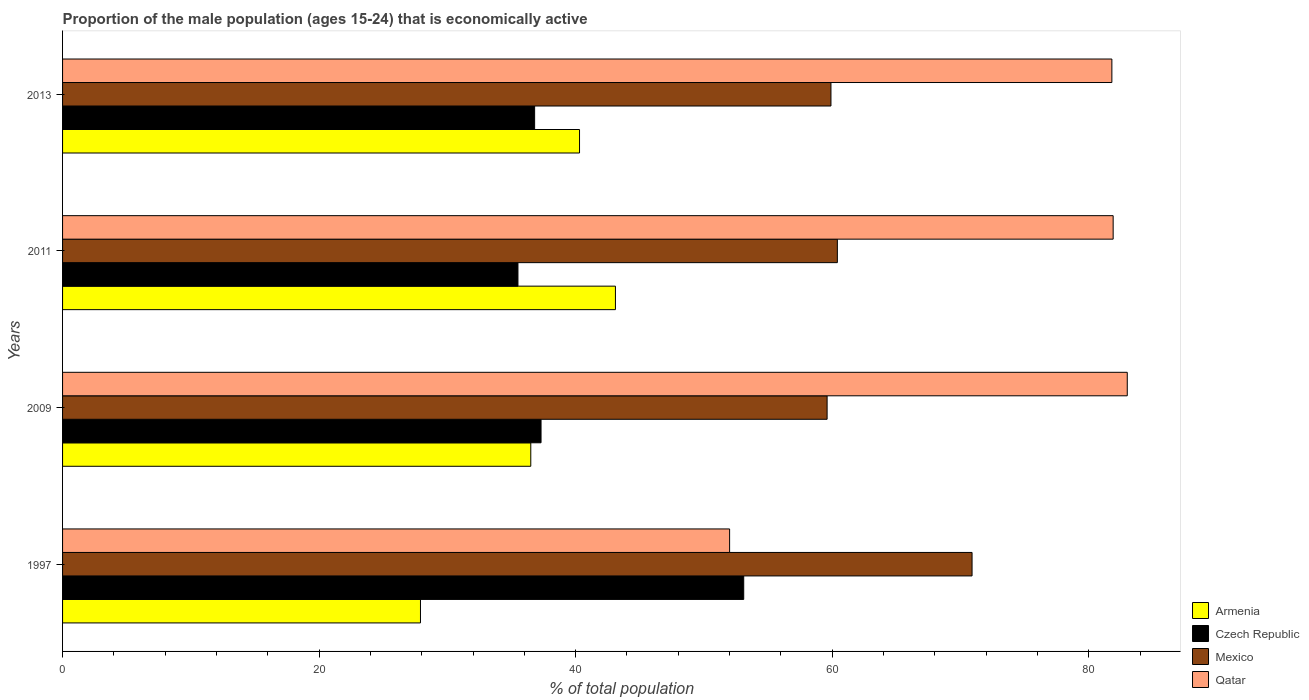How many different coloured bars are there?
Provide a short and direct response. 4. How many groups of bars are there?
Provide a succinct answer. 4. Are the number of bars on each tick of the Y-axis equal?
Offer a very short reply. Yes. What is the proportion of the male population that is economically active in Mexico in 1997?
Your response must be concise. 70.9. Across all years, what is the minimum proportion of the male population that is economically active in Mexico?
Your response must be concise. 59.6. In which year was the proportion of the male population that is economically active in Armenia maximum?
Provide a short and direct response. 2011. What is the total proportion of the male population that is economically active in Czech Republic in the graph?
Your answer should be very brief. 162.7. What is the difference between the proportion of the male population that is economically active in Qatar in 1997 and that in 2011?
Make the answer very short. -29.9. What is the difference between the proportion of the male population that is economically active in Mexico in 2011 and the proportion of the male population that is economically active in Czech Republic in 2013?
Provide a short and direct response. 23.6. What is the average proportion of the male population that is economically active in Czech Republic per year?
Make the answer very short. 40.67. In the year 2011, what is the difference between the proportion of the male population that is economically active in Mexico and proportion of the male population that is economically active in Czech Republic?
Offer a very short reply. 24.9. In how many years, is the proportion of the male population that is economically active in Qatar greater than 56 %?
Your response must be concise. 3. What is the ratio of the proportion of the male population that is economically active in Armenia in 2009 to that in 2011?
Your answer should be very brief. 0.85. Is the proportion of the male population that is economically active in Armenia in 1997 less than that in 2009?
Your answer should be very brief. Yes. What is the difference between the highest and the second highest proportion of the male population that is economically active in Mexico?
Your response must be concise. 10.5. Is the sum of the proportion of the male population that is economically active in Qatar in 2009 and 2013 greater than the maximum proportion of the male population that is economically active in Armenia across all years?
Your response must be concise. Yes. Is it the case that in every year, the sum of the proportion of the male population that is economically active in Czech Republic and proportion of the male population that is economically active in Qatar is greater than the sum of proportion of the male population that is economically active in Mexico and proportion of the male population that is economically active in Armenia?
Your answer should be compact. Yes. What does the 4th bar from the top in 1997 represents?
Offer a very short reply. Armenia. What does the 2nd bar from the bottom in 1997 represents?
Offer a terse response. Czech Republic. How many bars are there?
Offer a terse response. 16. Are all the bars in the graph horizontal?
Ensure brevity in your answer.  Yes. How many years are there in the graph?
Give a very brief answer. 4. What is the difference between two consecutive major ticks on the X-axis?
Keep it short and to the point. 20. Are the values on the major ticks of X-axis written in scientific E-notation?
Your answer should be very brief. No. Does the graph contain any zero values?
Offer a terse response. No. Does the graph contain grids?
Provide a short and direct response. No. Where does the legend appear in the graph?
Your response must be concise. Bottom right. How many legend labels are there?
Provide a succinct answer. 4. How are the legend labels stacked?
Ensure brevity in your answer.  Vertical. What is the title of the graph?
Make the answer very short. Proportion of the male population (ages 15-24) that is economically active. Does "New Zealand" appear as one of the legend labels in the graph?
Your answer should be compact. No. What is the label or title of the X-axis?
Provide a short and direct response. % of total population. What is the % of total population in Armenia in 1997?
Provide a succinct answer. 27.9. What is the % of total population of Czech Republic in 1997?
Give a very brief answer. 53.1. What is the % of total population of Mexico in 1997?
Provide a short and direct response. 70.9. What is the % of total population of Armenia in 2009?
Your answer should be compact. 36.5. What is the % of total population in Czech Republic in 2009?
Your answer should be compact. 37.3. What is the % of total population of Mexico in 2009?
Provide a short and direct response. 59.6. What is the % of total population in Armenia in 2011?
Make the answer very short. 43.1. What is the % of total population of Czech Republic in 2011?
Your answer should be compact. 35.5. What is the % of total population of Mexico in 2011?
Make the answer very short. 60.4. What is the % of total population in Qatar in 2011?
Give a very brief answer. 81.9. What is the % of total population of Armenia in 2013?
Offer a very short reply. 40.3. What is the % of total population in Czech Republic in 2013?
Your answer should be very brief. 36.8. What is the % of total population of Mexico in 2013?
Ensure brevity in your answer.  59.9. What is the % of total population in Qatar in 2013?
Your response must be concise. 81.8. Across all years, what is the maximum % of total population of Armenia?
Keep it short and to the point. 43.1. Across all years, what is the maximum % of total population in Czech Republic?
Your answer should be compact. 53.1. Across all years, what is the maximum % of total population in Mexico?
Provide a short and direct response. 70.9. Across all years, what is the maximum % of total population of Qatar?
Give a very brief answer. 83. Across all years, what is the minimum % of total population of Armenia?
Provide a succinct answer. 27.9. Across all years, what is the minimum % of total population in Czech Republic?
Provide a short and direct response. 35.5. Across all years, what is the minimum % of total population in Mexico?
Give a very brief answer. 59.6. What is the total % of total population in Armenia in the graph?
Make the answer very short. 147.8. What is the total % of total population of Czech Republic in the graph?
Give a very brief answer. 162.7. What is the total % of total population in Mexico in the graph?
Offer a very short reply. 250.8. What is the total % of total population in Qatar in the graph?
Give a very brief answer. 298.7. What is the difference between the % of total population of Czech Republic in 1997 and that in 2009?
Your answer should be very brief. 15.8. What is the difference between the % of total population of Qatar in 1997 and that in 2009?
Make the answer very short. -31. What is the difference between the % of total population in Armenia in 1997 and that in 2011?
Offer a terse response. -15.2. What is the difference between the % of total population in Qatar in 1997 and that in 2011?
Your answer should be very brief. -29.9. What is the difference between the % of total population of Armenia in 1997 and that in 2013?
Ensure brevity in your answer.  -12.4. What is the difference between the % of total population of Czech Republic in 1997 and that in 2013?
Provide a short and direct response. 16.3. What is the difference between the % of total population of Qatar in 1997 and that in 2013?
Your response must be concise. -29.8. What is the difference between the % of total population in Czech Republic in 2009 and that in 2011?
Make the answer very short. 1.8. What is the difference between the % of total population in Qatar in 2009 and that in 2011?
Give a very brief answer. 1.1. What is the difference between the % of total population of Czech Republic in 2009 and that in 2013?
Your response must be concise. 0.5. What is the difference between the % of total population of Mexico in 2009 and that in 2013?
Provide a succinct answer. -0.3. What is the difference between the % of total population of Armenia in 1997 and the % of total population of Mexico in 2009?
Ensure brevity in your answer.  -31.7. What is the difference between the % of total population in Armenia in 1997 and the % of total population in Qatar in 2009?
Keep it short and to the point. -55.1. What is the difference between the % of total population of Czech Republic in 1997 and the % of total population of Mexico in 2009?
Keep it short and to the point. -6.5. What is the difference between the % of total population of Czech Republic in 1997 and the % of total population of Qatar in 2009?
Your answer should be very brief. -29.9. What is the difference between the % of total population of Armenia in 1997 and the % of total population of Mexico in 2011?
Your answer should be compact. -32.5. What is the difference between the % of total population in Armenia in 1997 and the % of total population in Qatar in 2011?
Your response must be concise. -54. What is the difference between the % of total population of Czech Republic in 1997 and the % of total population of Mexico in 2011?
Your answer should be compact. -7.3. What is the difference between the % of total population in Czech Republic in 1997 and the % of total population in Qatar in 2011?
Make the answer very short. -28.8. What is the difference between the % of total population in Mexico in 1997 and the % of total population in Qatar in 2011?
Offer a very short reply. -11. What is the difference between the % of total population of Armenia in 1997 and the % of total population of Czech Republic in 2013?
Your answer should be very brief. -8.9. What is the difference between the % of total population in Armenia in 1997 and the % of total population in Mexico in 2013?
Offer a terse response. -32. What is the difference between the % of total population in Armenia in 1997 and the % of total population in Qatar in 2013?
Your answer should be compact. -53.9. What is the difference between the % of total population of Czech Republic in 1997 and the % of total population of Qatar in 2013?
Your answer should be compact. -28.7. What is the difference between the % of total population in Mexico in 1997 and the % of total population in Qatar in 2013?
Offer a terse response. -10.9. What is the difference between the % of total population in Armenia in 2009 and the % of total population in Mexico in 2011?
Your response must be concise. -23.9. What is the difference between the % of total population in Armenia in 2009 and the % of total population in Qatar in 2011?
Your response must be concise. -45.4. What is the difference between the % of total population of Czech Republic in 2009 and the % of total population of Mexico in 2011?
Give a very brief answer. -23.1. What is the difference between the % of total population of Czech Republic in 2009 and the % of total population of Qatar in 2011?
Your answer should be very brief. -44.6. What is the difference between the % of total population in Mexico in 2009 and the % of total population in Qatar in 2011?
Offer a very short reply. -22.3. What is the difference between the % of total population in Armenia in 2009 and the % of total population in Czech Republic in 2013?
Offer a terse response. -0.3. What is the difference between the % of total population of Armenia in 2009 and the % of total population of Mexico in 2013?
Provide a succinct answer. -23.4. What is the difference between the % of total population in Armenia in 2009 and the % of total population in Qatar in 2013?
Your answer should be very brief. -45.3. What is the difference between the % of total population in Czech Republic in 2009 and the % of total population in Mexico in 2013?
Make the answer very short. -22.6. What is the difference between the % of total population of Czech Republic in 2009 and the % of total population of Qatar in 2013?
Your response must be concise. -44.5. What is the difference between the % of total population in Mexico in 2009 and the % of total population in Qatar in 2013?
Make the answer very short. -22.2. What is the difference between the % of total population of Armenia in 2011 and the % of total population of Czech Republic in 2013?
Offer a very short reply. 6.3. What is the difference between the % of total population of Armenia in 2011 and the % of total population of Mexico in 2013?
Keep it short and to the point. -16.8. What is the difference between the % of total population of Armenia in 2011 and the % of total population of Qatar in 2013?
Offer a terse response. -38.7. What is the difference between the % of total population in Czech Republic in 2011 and the % of total population in Mexico in 2013?
Offer a very short reply. -24.4. What is the difference between the % of total population of Czech Republic in 2011 and the % of total population of Qatar in 2013?
Give a very brief answer. -46.3. What is the difference between the % of total population of Mexico in 2011 and the % of total population of Qatar in 2013?
Make the answer very short. -21.4. What is the average % of total population of Armenia per year?
Keep it short and to the point. 36.95. What is the average % of total population of Czech Republic per year?
Your answer should be compact. 40.67. What is the average % of total population of Mexico per year?
Ensure brevity in your answer.  62.7. What is the average % of total population of Qatar per year?
Provide a succinct answer. 74.67. In the year 1997, what is the difference between the % of total population in Armenia and % of total population in Czech Republic?
Ensure brevity in your answer.  -25.2. In the year 1997, what is the difference between the % of total population in Armenia and % of total population in Mexico?
Make the answer very short. -43. In the year 1997, what is the difference between the % of total population in Armenia and % of total population in Qatar?
Provide a short and direct response. -24.1. In the year 1997, what is the difference between the % of total population of Czech Republic and % of total population of Mexico?
Make the answer very short. -17.8. In the year 1997, what is the difference between the % of total population in Mexico and % of total population in Qatar?
Make the answer very short. 18.9. In the year 2009, what is the difference between the % of total population of Armenia and % of total population of Czech Republic?
Your answer should be very brief. -0.8. In the year 2009, what is the difference between the % of total population in Armenia and % of total population in Mexico?
Make the answer very short. -23.1. In the year 2009, what is the difference between the % of total population in Armenia and % of total population in Qatar?
Your response must be concise. -46.5. In the year 2009, what is the difference between the % of total population of Czech Republic and % of total population of Mexico?
Ensure brevity in your answer.  -22.3. In the year 2009, what is the difference between the % of total population of Czech Republic and % of total population of Qatar?
Your answer should be compact. -45.7. In the year 2009, what is the difference between the % of total population in Mexico and % of total population in Qatar?
Offer a terse response. -23.4. In the year 2011, what is the difference between the % of total population in Armenia and % of total population in Mexico?
Make the answer very short. -17.3. In the year 2011, what is the difference between the % of total population in Armenia and % of total population in Qatar?
Provide a succinct answer. -38.8. In the year 2011, what is the difference between the % of total population in Czech Republic and % of total population in Mexico?
Give a very brief answer. -24.9. In the year 2011, what is the difference between the % of total population in Czech Republic and % of total population in Qatar?
Keep it short and to the point. -46.4. In the year 2011, what is the difference between the % of total population of Mexico and % of total population of Qatar?
Ensure brevity in your answer.  -21.5. In the year 2013, what is the difference between the % of total population of Armenia and % of total population of Mexico?
Offer a very short reply. -19.6. In the year 2013, what is the difference between the % of total population of Armenia and % of total population of Qatar?
Provide a succinct answer. -41.5. In the year 2013, what is the difference between the % of total population in Czech Republic and % of total population in Mexico?
Ensure brevity in your answer.  -23.1. In the year 2013, what is the difference between the % of total population of Czech Republic and % of total population of Qatar?
Your answer should be compact. -45. In the year 2013, what is the difference between the % of total population of Mexico and % of total population of Qatar?
Provide a short and direct response. -21.9. What is the ratio of the % of total population in Armenia in 1997 to that in 2009?
Make the answer very short. 0.76. What is the ratio of the % of total population of Czech Republic in 1997 to that in 2009?
Make the answer very short. 1.42. What is the ratio of the % of total population of Mexico in 1997 to that in 2009?
Ensure brevity in your answer.  1.19. What is the ratio of the % of total population of Qatar in 1997 to that in 2009?
Make the answer very short. 0.63. What is the ratio of the % of total population in Armenia in 1997 to that in 2011?
Your response must be concise. 0.65. What is the ratio of the % of total population of Czech Republic in 1997 to that in 2011?
Offer a very short reply. 1.5. What is the ratio of the % of total population of Mexico in 1997 to that in 2011?
Offer a terse response. 1.17. What is the ratio of the % of total population of Qatar in 1997 to that in 2011?
Provide a short and direct response. 0.63. What is the ratio of the % of total population of Armenia in 1997 to that in 2013?
Your answer should be compact. 0.69. What is the ratio of the % of total population of Czech Republic in 1997 to that in 2013?
Provide a short and direct response. 1.44. What is the ratio of the % of total population of Mexico in 1997 to that in 2013?
Your answer should be compact. 1.18. What is the ratio of the % of total population in Qatar in 1997 to that in 2013?
Provide a succinct answer. 0.64. What is the ratio of the % of total population in Armenia in 2009 to that in 2011?
Provide a short and direct response. 0.85. What is the ratio of the % of total population in Czech Republic in 2009 to that in 2011?
Make the answer very short. 1.05. What is the ratio of the % of total population of Mexico in 2009 to that in 2011?
Your answer should be very brief. 0.99. What is the ratio of the % of total population in Qatar in 2009 to that in 2011?
Ensure brevity in your answer.  1.01. What is the ratio of the % of total population of Armenia in 2009 to that in 2013?
Offer a terse response. 0.91. What is the ratio of the % of total population in Czech Republic in 2009 to that in 2013?
Provide a short and direct response. 1.01. What is the ratio of the % of total population of Mexico in 2009 to that in 2013?
Ensure brevity in your answer.  0.99. What is the ratio of the % of total population of Qatar in 2009 to that in 2013?
Offer a very short reply. 1.01. What is the ratio of the % of total population in Armenia in 2011 to that in 2013?
Offer a very short reply. 1.07. What is the ratio of the % of total population of Czech Republic in 2011 to that in 2013?
Your answer should be very brief. 0.96. What is the ratio of the % of total population of Mexico in 2011 to that in 2013?
Your response must be concise. 1.01. What is the difference between the highest and the second highest % of total population in Mexico?
Provide a short and direct response. 10.5. What is the difference between the highest and the lowest % of total population of Armenia?
Keep it short and to the point. 15.2. 